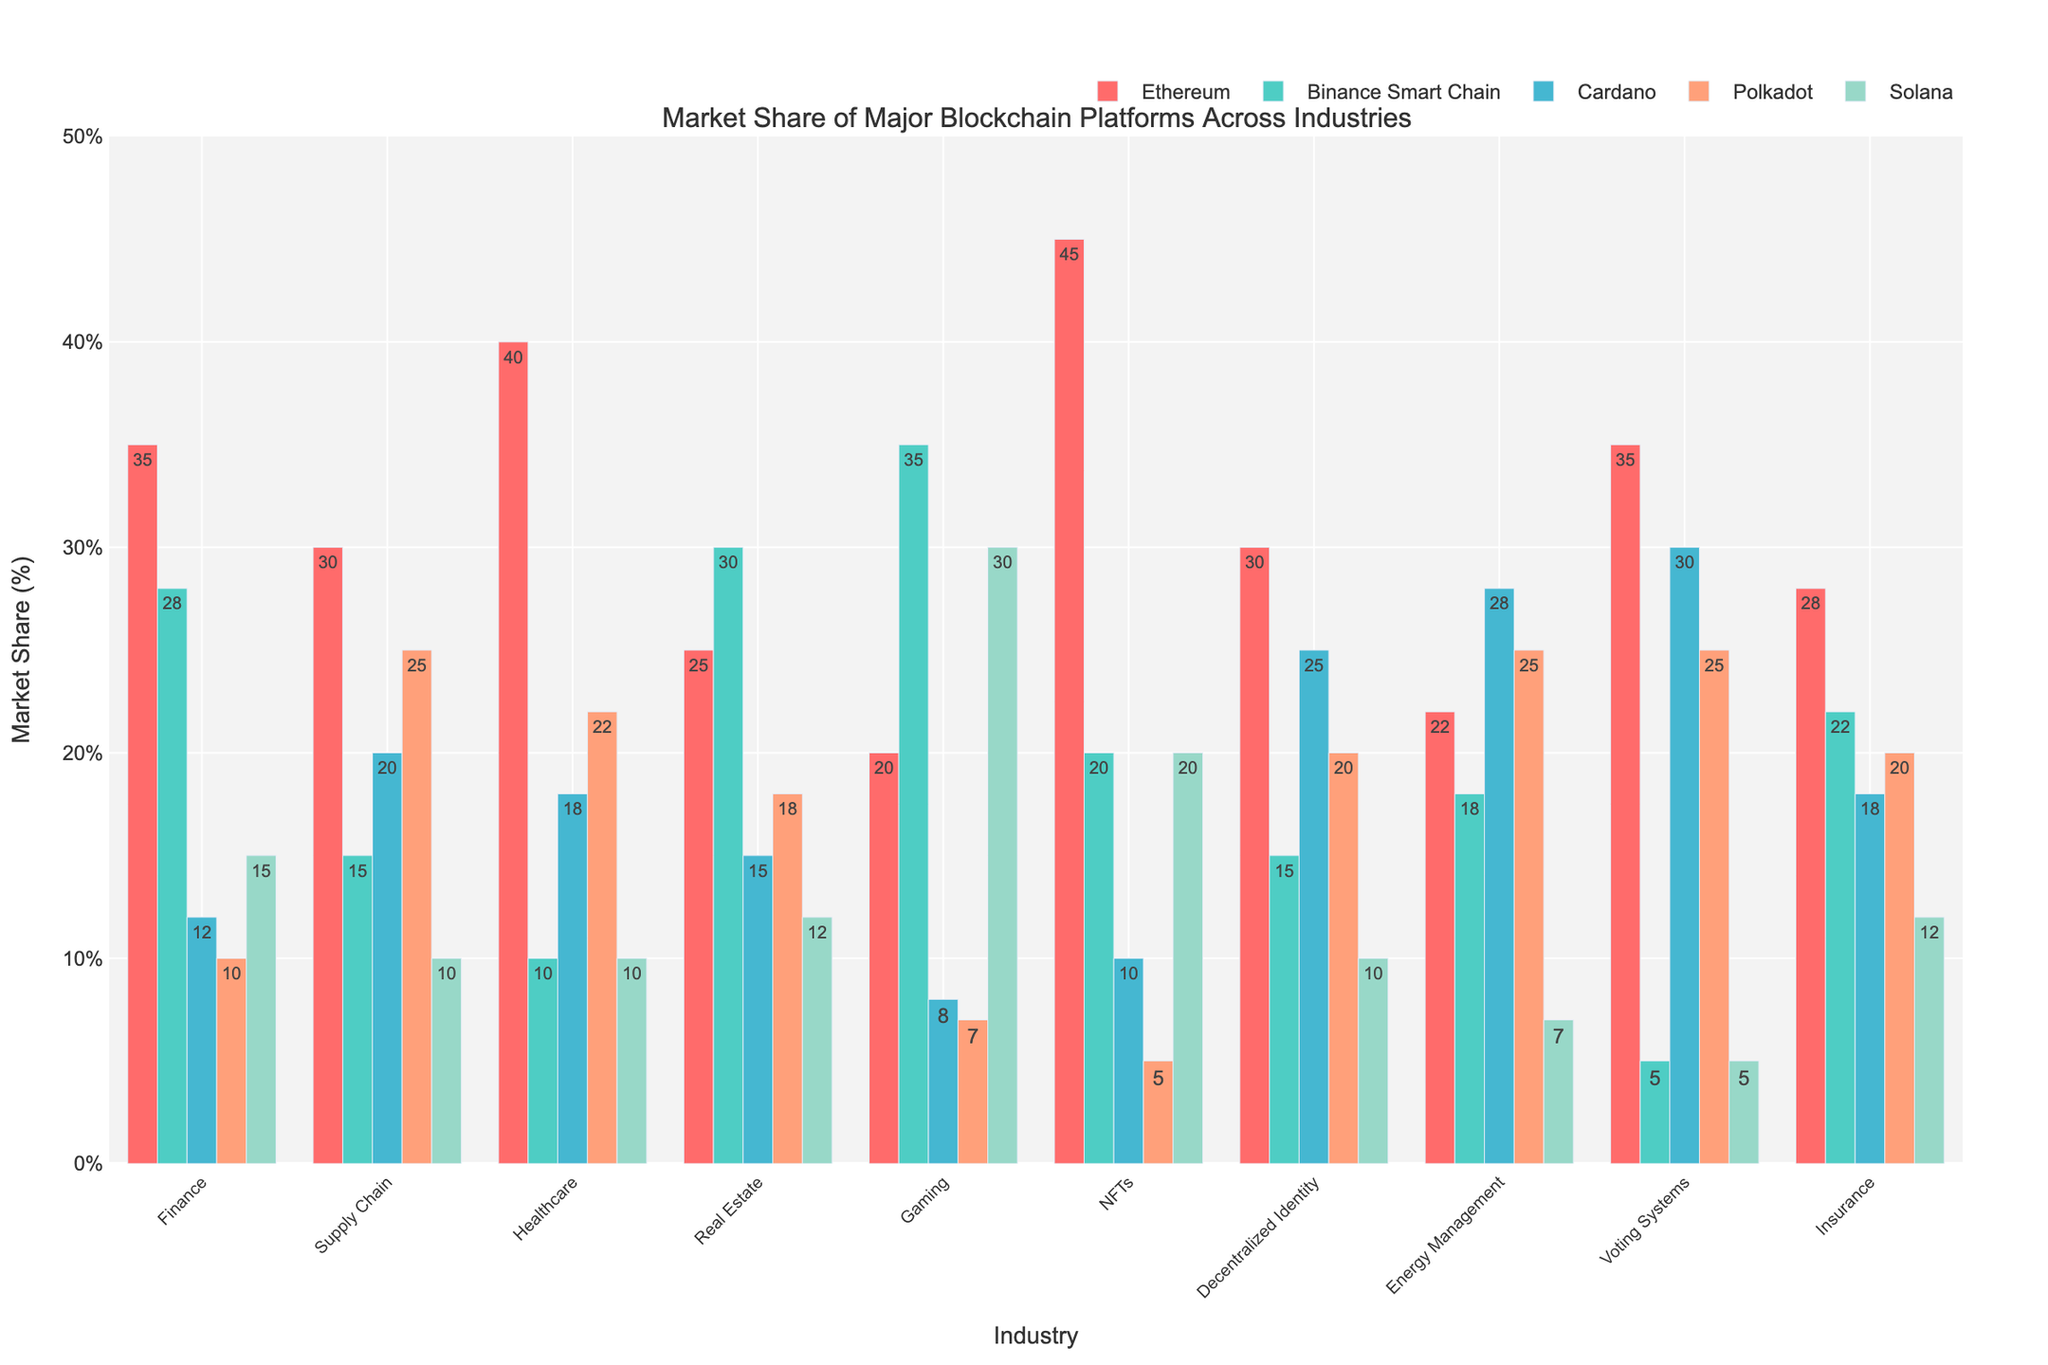What's the leading blockchain platform in the finance industry? Refer to the finance industry bar heights in the chart. The highest bar corresponds to Ethereum with a market share of 35%.
Answer: Ethereum Which industry has the highest market share for NFTs? Look at the NFTs section and compare the bars. Ethereum leads with a market share of 45%.
Answer: Ethereum Compare the market share of Solana in Gaming and Healthcare. Which industry has a higher share? Compare the heights of the Solana bars in the Gaming and Healthcare sections. Solana has a higher share in Gaming with 30%, compared to Healthcare with 10%.
Answer: Gaming What is the combined market share of Cardano in Finance and Supply Chain? Add the market share values of Cardano in Finance (12%) and Supply Chain (20%). 12 + 20 = 32%
Answer: 32% Which platform dominates the decentralized identity industry in terms of market share? Look at the Decentralized Identity section and identify the highest bar. Cardano has the highest market share at 25%.
Answer: Cardano In which industry does Binance Smart Chain have the largest market share? Compare Binance Smart Chain market shares across industries. The highest share is in the Gaming industry with 35%.
Answer: Gaming What is the difference in market share between Ethereum and Polkadot in the healthcare industry? Subtract the market share of Polkadot (22%) in Healthcare from Ethereum’s market share (40%). 40 - 22 = 18%
Answer: 18% Which two platforms have similar market shares in Energy Management? Compare bar heights in the Energy Management industry. Polkadot (25%) and Binance Smart Chain (25%) have similar market shares.
Answer: Polkadot and Binance Smart Chain What is the average market share of all platforms in the Insurance industry? Sum the market shares of Ethereum (28%), Binance Smart Chain (22%), Cardano (18%), Polkadot (20%), and Solana (12%). Then divide by the number of platforms (5). (28 + 22 + 18 + 20 + 12) / 5 = 20%
Answer: 20% Which blockchain platform shows the most consistent market share across all industries? Assess the variability of each platform's market share across the industries. Ethereum generally maintains a high market share across many industries.
Answer: Ethereum 